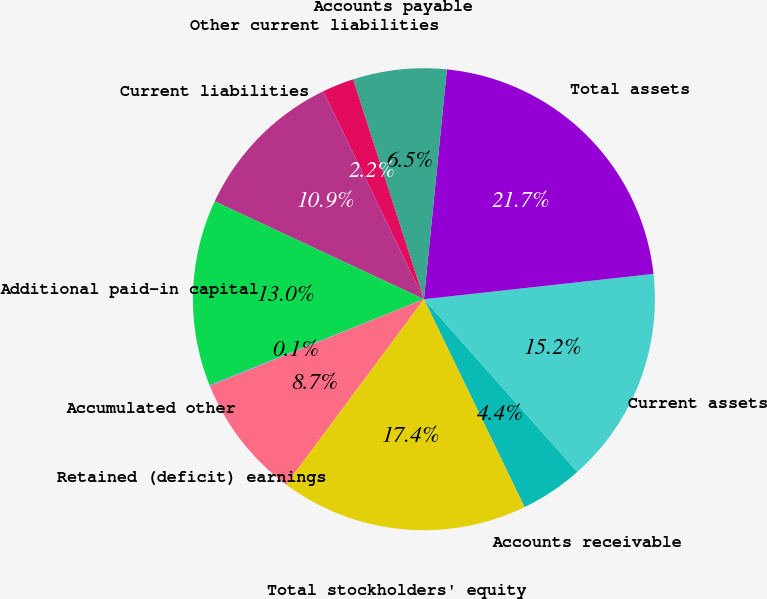Convert chart. <chart><loc_0><loc_0><loc_500><loc_500><pie_chart><fcel>Accounts receivable<fcel>Current assets<fcel>Total assets<fcel>Accounts payable<fcel>Other current liabilities<fcel>Current liabilities<fcel>Additional paid-in capital<fcel>Accumulated other<fcel>Retained (deficit) earnings<fcel>Total stockholders' equity<nl><fcel>4.38%<fcel>15.19%<fcel>21.67%<fcel>6.54%<fcel>2.22%<fcel>10.86%<fcel>13.03%<fcel>0.06%<fcel>8.7%<fcel>17.35%<nl></chart> 